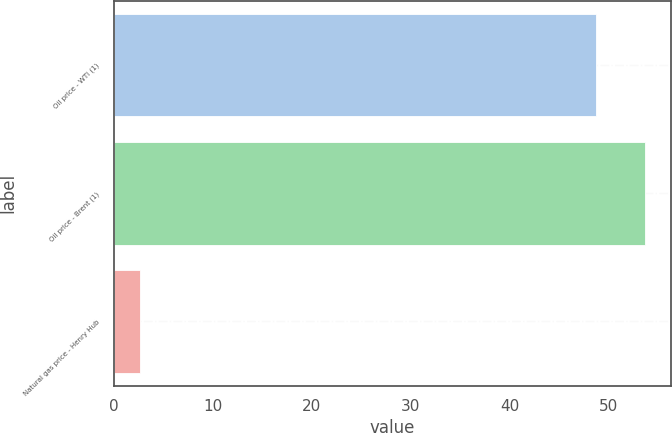Convert chart to OTSL. <chart><loc_0><loc_0><loc_500><loc_500><bar_chart><fcel>Oil price - WTI (1)<fcel>Oil price - Brent (1)<fcel>Natural gas price - Henry Hub<nl><fcel>48.69<fcel>53.66<fcel>2.63<nl></chart> 